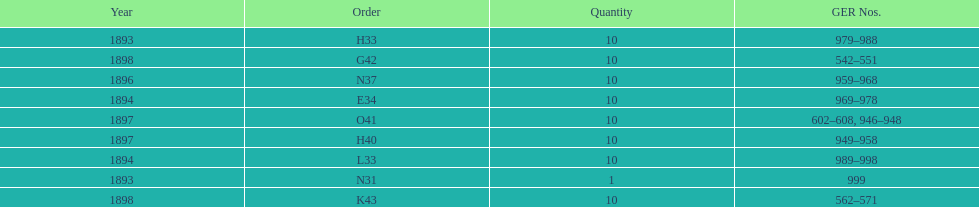Were there more n31 or e34 ordered? E34. 